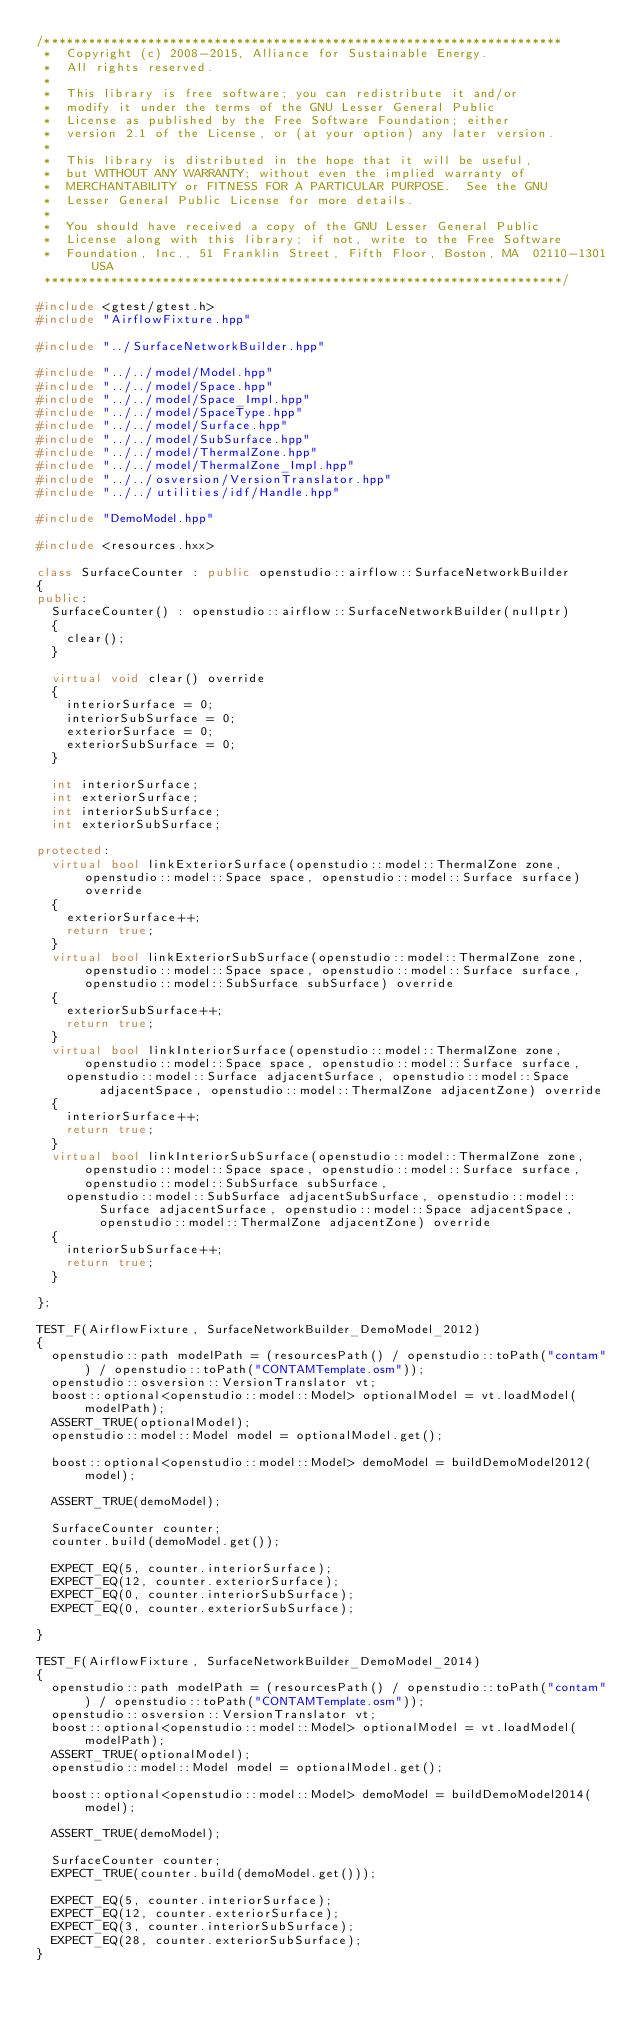Convert code to text. <code><loc_0><loc_0><loc_500><loc_500><_C++_>/**********************************************************************
 *  Copyright (c) 2008-2015, Alliance for Sustainable Energy.
 *  All rights reserved.
 *
 *  This library is free software; you can redistribute it and/or
 *  modify it under the terms of the GNU Lesser General Public
 *  License as published by the Free Software Foundation; either
 *  version 2.1 of the License, or (at your option) any later version.
 *
 *  This library is distributed in the hope that it will be useful,
 *  but WITHOUT ANY WARRANTY; without even the implied warranty of
 *  MERCHANTABILITY or FITNESS FOR A PARTICULAR PURPOSE.  See the GNU
 *  Lesser General Public License for more details.
 *
 *  You should have received a copy of the GNU Lesser General Public
 *  License along with this library; if not, write to the Free Software
 *  Foundation, Inc., 51 Franklin Street, Fifth Floor, Boston, MA  02110-1301  USA
 **********************************************************************/

#include <gtest/gtest.h>
#include "AirflowFixture.hpp"

#include "../SurfaceNetworkBuilder.hpp"

#include "../../model/Model.hpp"
#include "../../model/Space.hpp"
#include "../../model/Space_Impl.hpp"
#include "../../model/SpaceType.hpp"
#include "../../model/Surface.hpp"
#include "../../model/SubSurface.hpp"
#include "../../model/ThermalZone.hpp"
#include "../../model/ThermalZone_Impl.hpp"
#include "../../osversion/VersionTranslator.hpp"
#include "../../utilities/idf/Handle.hpp"

#include "DemoModel.hpp"

#include <resources.hxx>

class SurfaceCounter : public openstudio::airflow::SurfaceNetworkBuilder
{
public:
  SurfaceCounter() : openstudio::airflow::SurfaceNetworkBuilder(nullptr)
  {
    clear();
  }
  
  virtual void clear() override
  {
    interiorSurface = 0;
    interiorSubSurface = 0;
    exteriorSurface = 0;
    exteriorSubSurface = 0;
  }

  int interiorSurface;
  int exteriorSurface;
  int interiorSubSurface;
  int exteriorSubSurface;

protected:
  virtual bool linkExteriorSurface(openstudio::model::ThermalZone zone, openstudio::model::Space space, openstudio::model::Surface surface) override
  {
    exteriorSurface++;
    return true;
  }
  virtual bool linkExteriorSubSurface(openstudio::model::ThermalZone zone, openstudio::model::Space space, openstudio::model::Surface surface, openstudio::model::SubSurface subSurface) override
  {
    exteriorSubSurface++;
    return true;
  }
  virtual bool linkInteriorSurface(openstudio::model::ThermalZone zone, openstudio::model::Space space, openstudio::model::Surface surface,
    openstudio::model::Surface adjacentSurface, openstudio::model::Space adjacentSpace, openstudio::model::ThermalZone adjacentZone) override
  {
    interiorSurface++;
    return true;
  }
  virtual bool linkInteriorSubSurface(openstudio::model::ThermalZone zone, openstudio::model::Space space, openstudio::model::Surface surface, openstudio::model::SubSurface subSurface,
    openstudio::model::SubSurface adjacentSubSurface, openstudio::model::Surface adjacentSurface, openstudio::model::Space adjacentSpace, openstudio::model::ThermalZone adjacentZone) override
  {
    interiorSubSurface++;
    return true;
  }

};

TEST_F(AirflowFixture, SurfaceNetworkBuilder_DemoModel_2012)
{
  openstudio::path modelPath = (resourcesPath() / openstudio::toPath("contam") / openstudio::toPath("CONTAMTemplate.osm"));
  openstudio::osversion::VersionTranslator vt;
  boost::optional<openstudio::model::Model> optionalModel = vt.loadModel(modelPath);
  ASSERT_TRUE(optionalModel);
  openstudio::model::Model model = optionalModel.get();

  boost::optional<openstudio::model::Model> demoModel = buildDemoModel2012(model);

  ASSERT_TRUE(demoModel);

  SurfaceCounter counter;
  counter.build(demoModel.get());

  EXPECT_EQ(5, counter.interiorSurface);
  EXPECT_EQ(12, counter.exteriorSurface);
  EXPECT_EQ(0, counter.interiorSubSurface);
  EXPECT_EQ(0, counter.exteriorSubSurface);

}

TEST_F(AirflowFixture, SurfaceNetworkBuilder_DemoModel_2014)
{
  openstudio::path modelPath = (resourcesPath() / openstudio::toPath("contam") / openstudio::toPath("CONTAMTemplate.osm"));
  openstudio::osversion::VersionTranslator vt;
  boost::optional<openstudio::model::Model> optionalModel = vt.loadModel(modelPath);
  ASSERT_TRUE(optionalModel);
  openstudio::model::Model model = optionalModel.get();

  boost::optional<openstudio::model::Model> demoModel = buildDemoModel2014(model);

  ASSERT_TRUE(demoModel);

  SurfaceCounter counter;
  EXPECT_TRUE(counter.build(demoModel.get()));

  EXPECT_EQ(5, counter.interiorSurface);
  EXPECT_EQ(12, counter.exteriorSurface);
  EXPECT_EQ(3, counter.interiorSubSurface);
  EXPECT_EQ(28, counter.exteriorSubSurface);
}</code> 